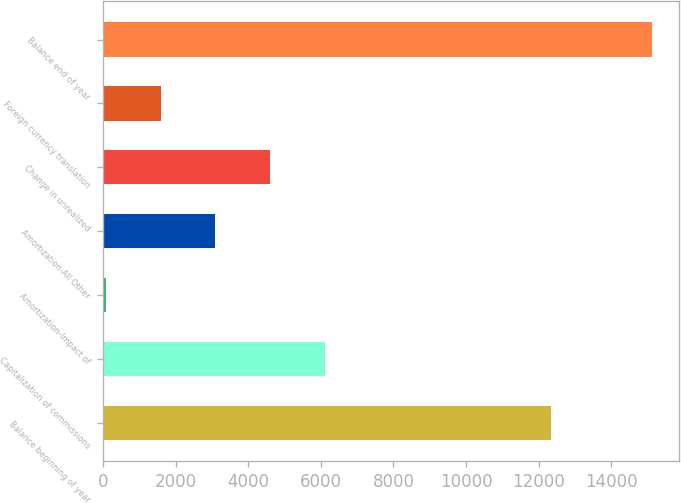<chart> <loc_0><loc_0><loc_500><loc_500><bar_chart><fcel>Balance beginning of year<fcel>Capitalization of commissions<fcel>Amortization-Impact of<fcel>Amortization-All Other<fcel>Change in unrealized<fcel>Foreign currency translation<fcel>Balance end of year<nl><fcel>12339<fcel>6102.6<fcel>87<fcel>3094.8<fcel>4598.7<fcel>1590.9<fcel>15126<nl></chart> 